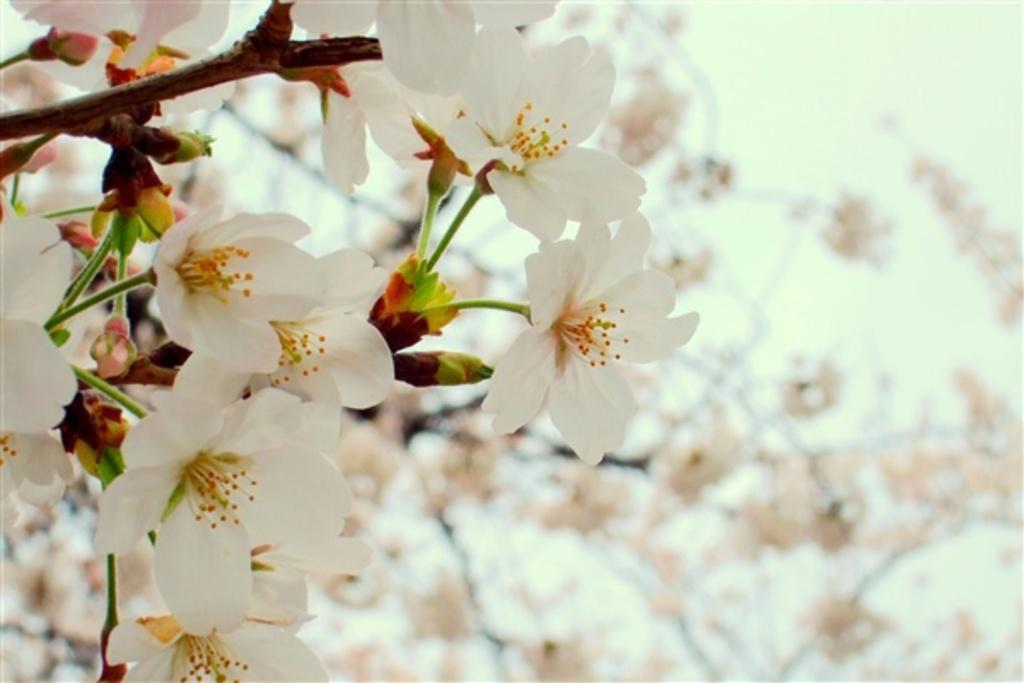Could you give a brief overview of what you see in this image? In this picture we can see flowers and there is a blur background. 